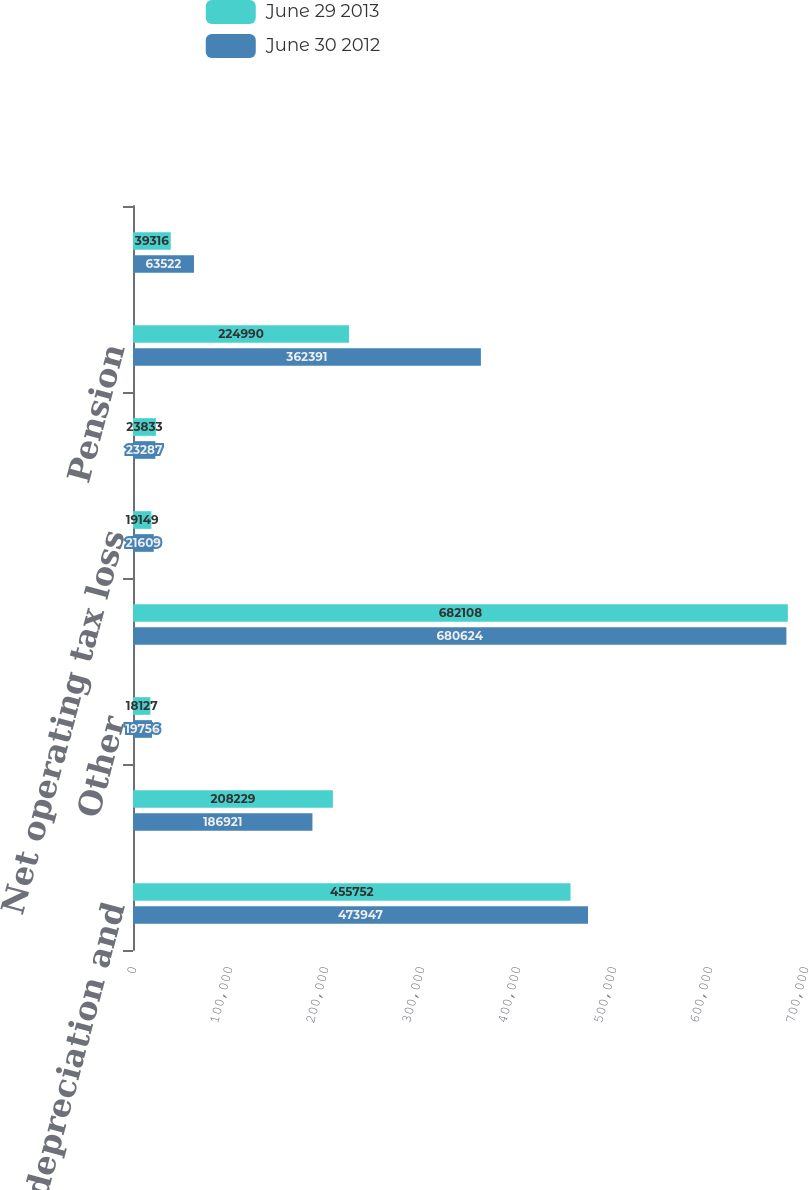Convert chart. <chart><loc_0><loc_0><loc_500><loc_500><stacked_bar_chart><ecel><fcel>Excess tax depreciation and<fcel>Goodwill and intangible assets<fcel>Other<fcel>Total deferred tax liabilities<fcel>Net operating tax loss<fcel>Benefit on unrecognized tax<fcel>Pension<fcel>Share-based compensation<nl><fcel>June 29 2013<fcel>455752<fcel>208229<fcel>18127<fcel>682108<fcel>19149<fcel>23833<fcel>224990<fcel>39316<nl><fcel>June 30 2012<fcel>473947<fcel>186921<fcel>19756<fcel>680624<fcel>21609<fcel>23287<fcel>362391<fcel>63522<nl></chart> 